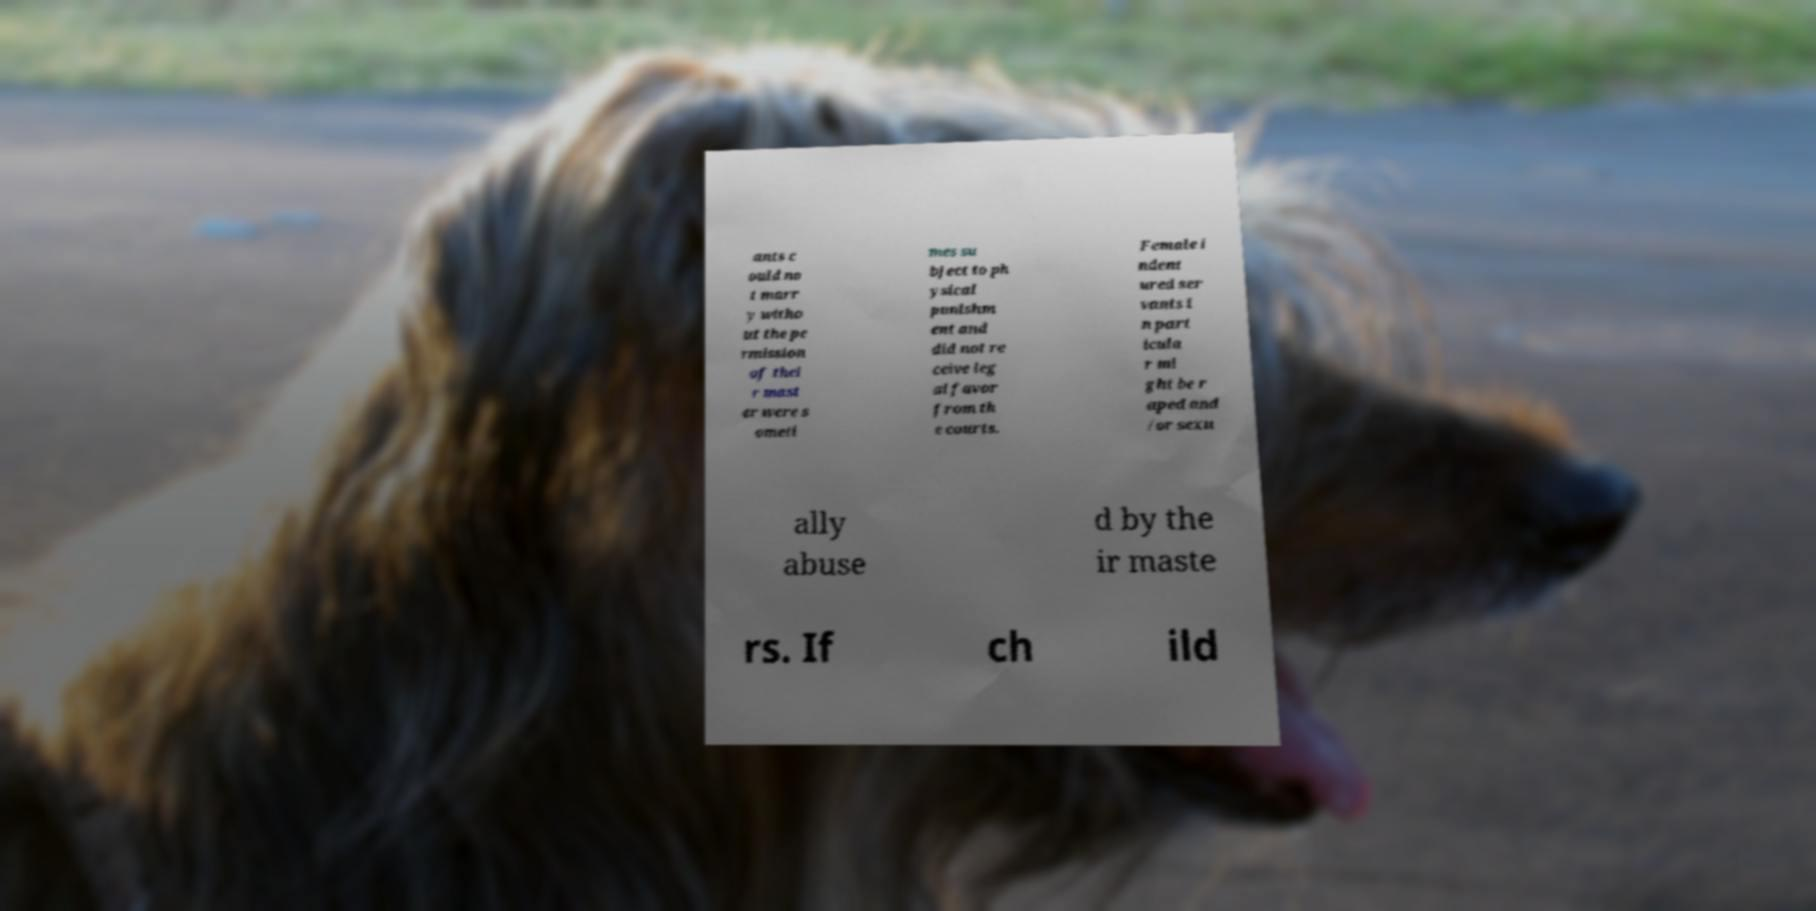Please identify and transcribe the text found in this image. ants c ould no t marr y witho ut the pe rmission of thei r mast er were s ometi mes su bject to ph ysical punishm ent and did not re ceive leg al favor from th e courts. Female i ndent ured ser vants i n part icula r mi ght be r aped and /or sexu ally abuse d by the ir maste rs. If ch ild 